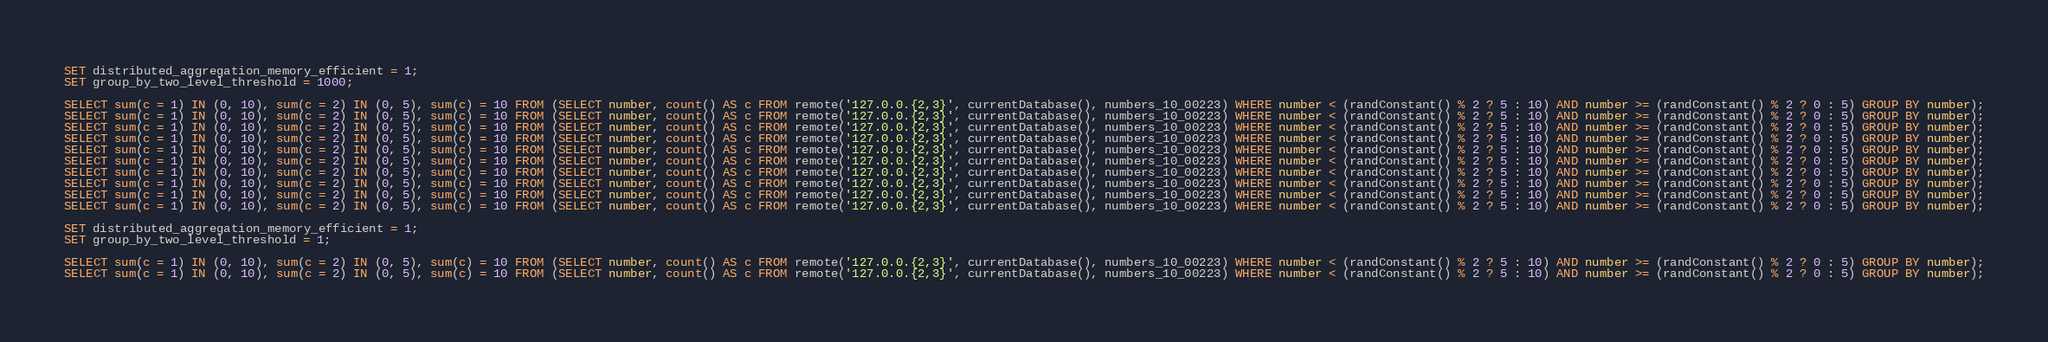Convert code to text. <code><loc_0><loc_0><loc_500><loc_500><_SQL_>
SET distributed_aggregation_memory_efficient = 1;
SET group_by_two_level_threshold = 1000;

SELECT sum(c = 1) IN (0, 10), sum(c = 2) IN (0, 5), sum(c) = 10 FROM (SELECT number, count() AS c FROM remote('127.0.0.{2,3}', currentDatabase(), numbers_10_00223) WHERE number < (randConstant() % 2 ? 5 : 10) AND number >= (randConstant() % 2 ? 0 : 5) GROUP BY number);
SELECT sum(c = 1) IN (0, 10), sum(c = 2) IN (0, 5), sum(c) = 10 FROM (SELECT number, count() AS c FROM remote('127.0.0.{2,3}', currentDatabase(), numbers_10_00223) WHERE number < (randConstant() % 2 ? 5 : 10) AND number >= (randConstant() % 2 ? 0 : 5) GROUP BY number);
SELECT sum(c = 1) IN (0, 10), sum(c = 2) IN (0, 5), sum(c) = 10 FROM (SELECT number, count() AS c FROM remote('127.0.0.{2,3}', currentDatabase(), numbers_10_00223) WHERE number < (randConstant() % 2 ? 5 : 10) AND number >= (randConstant() % 2 ? 0 : 5) GROUP BY number);
SELECT sum(c = 1) IN (0, 10), sum(c = 2) IN (0, 5), sum(c) = 10 FROM (SELECT number, count() AS c FROM remote('127.0.0.{2,3}', currentDatabase(), numbers_10_00223) WHERE number < (randConstant() % 2 ? 5 : 10) AND number >= (randConstant() % 2 ? 0 : 5) GROUP BY number);
SELECT sum(c = 1) IN (0, 10), sum(c = 2) IN (0, 5), sum(c) = 10 FROM (SELECT number, count() AS c FROM remote('127.0.0.{2,3}', currentDatabase(), numbers_10_00223) WHERE number < (randConstant() % 2 ? 5 : 10) AND number >= (randConstant() % 2 ? 0 : 5) GROUP BY number);
SELECT sum(c = 1) IN (0, 10), sum(c = 2) IN (0, 5), sum(c) = 10 FROM (SELECT number, count() AS c FROM remote('127.0.0.{2,3}', currentDatabase(), numbers_10_00223) WHERE number < (randConstant() % 2 ? 5 : 10) AND number >= (randConstant() % 2 ? 0 : 5) GROUP BY number);
SELECT sum(c = 1) IN (0, 10), sum(c = 2) IN (0, 5), sum(c) = 10 FROM (SELECT number, count() AS c FROM remote('127.0.0.{2,3}', currentDatabase(), numbers_10_00223) WHERE number < (randConstant() % 2 ? 5 : 10) AND number >= (randConstant() % 2 ? 0 : 5) GROUP BY number);
SELECT sum(c = 1) IN (0, 10), sum(c = 2) IN (0, 5), sum(c) = 10 FROM (SELECT number, count() AS c FROM remote('127.0.0.{2,3}', currentDatabase(), numbers_10_00223) WHERE number < (randConstant() % 2 ? 5 : 10) AND number >= (randConstant() % 2 ? 0 : 5) GROUP BY number);
SELECT sum(c = 1) IN (0, 10), sum(c = 2) IN (0, 5), sum(c) = 10 FROM (SELECT number, count() AS c FROM remote('127.0.0.{2,3}', currentDatabase(), numbers_10_00223) WHERE number < (randConstant() % 2 ? 5 : 10) AND number >= (randConstant() % 2 ? 0 : 5) GROUP BY number);
SELECT sum(c = 1) IN (0, 10), sum(c = 2) IN (0, 5), sum(c) = 10 FROM (SELECT number, count() AS c FROM remote('127.0.0.{2,3}', currentDatabase(), numbers_10_00223) WHERE number < (randConstant() % 2 ? 5 : 10) AND number >= (randConstant() % 2 ? 0 : 5) GROUP BY number);

SET distributed_aggregation_memory_efficient = 1;
SET group_by_two_level_threshold = 1;

SELECT sum(c = 1) IN (0, 10), sum(c = 2) IN (0, 5), sum(c) = 10 FROM (SELECT number, count() AS c FROM remote('127.0.0.{2,3}', currentDatabase(), numbers_10_00223) WHERE number < (randConstant() % 2 ? 5 : 10) AND number >= (randConstant() % 2 ? 0 : 5) GROUP BY number);
SELECT sum(c = 1) IN (0, 10), sum(c = 2) IN (0, 5), sum(c) = 10 FROM (SELECT number, count() AS c FROM remote('127.0.0.{2,3}', currentDatabase(), numbers_10_00223) WHERE number < (randConstant() % 2 ? 5 : 10) AND number >= (randConstant() % 2 ? 0 : 5) GROUP BY number);</code> 